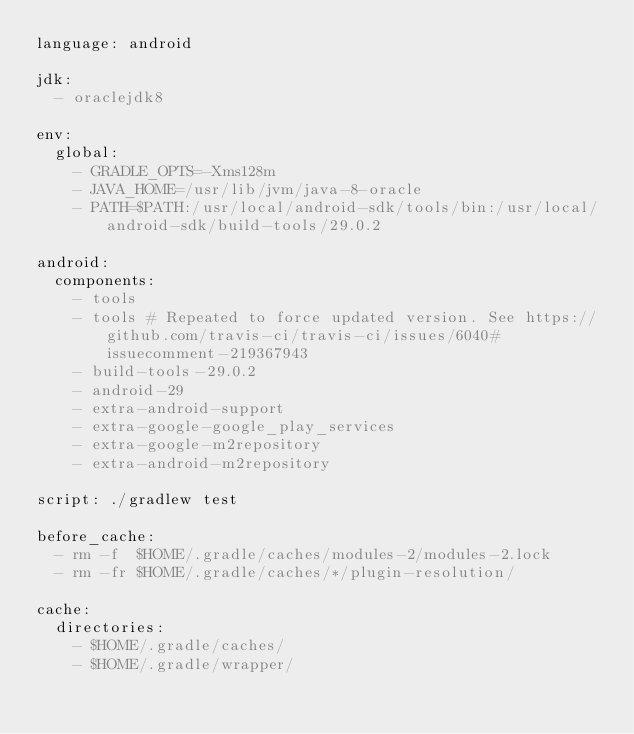Convert code to text. <code><loc_0><loc_0><loc_500><loc_500><_YAML_>language: android

jdk:
  - oraclejdk8

env:
  global:
    - GRADLE_OPTS=-Xms128m
    - JAVA_HOME=/usr/lib/jvm/java-8-oracle
    - PATH=$PATH:/usr/local/android-sdk/tools/bin:/usr/local/android-sdk/build-tools/29.0.2

android:
  components:
    - tools
    - tools # Repeated to force updated version. See https://github.com/travis-ci/travis-ci/issues/6040#issuecomment-219367943
    - build-tools-29.0.2
    - android-29
    - extra-android-support
    - extra-google-google_play_services
    - extra-google-m2repository
    - extra-android-m2repository

script: ./gradlew test

before_cache:
  - rm -f  $HOME/.gradle/caches/modules-2/modules-2.lock
  - rm -fr $HOME/.gradle/caches/*/plugin-resolution/

cache:
  directories:
    - $HOME/.gradle/caches/
    - $HOME/.gradle/wrapper/
</code> 